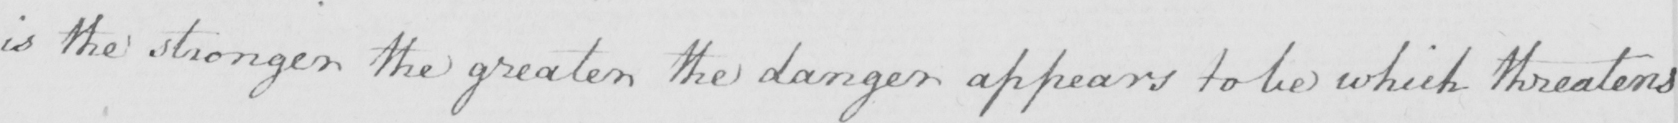Please provide the text content of this handwritten line. is the stronger the greater the danger appears to be which threatens 